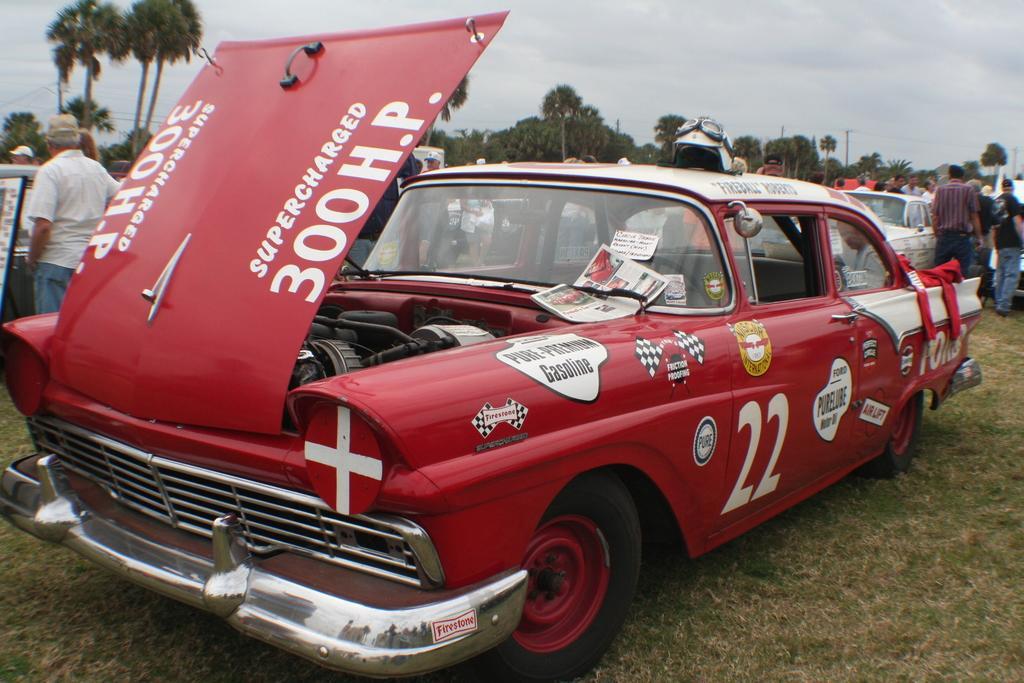Describe this image in one or two sentences. In the image I can see few colorful vehicles. I can see few trees and few people around. The sky is in blue and white color. 